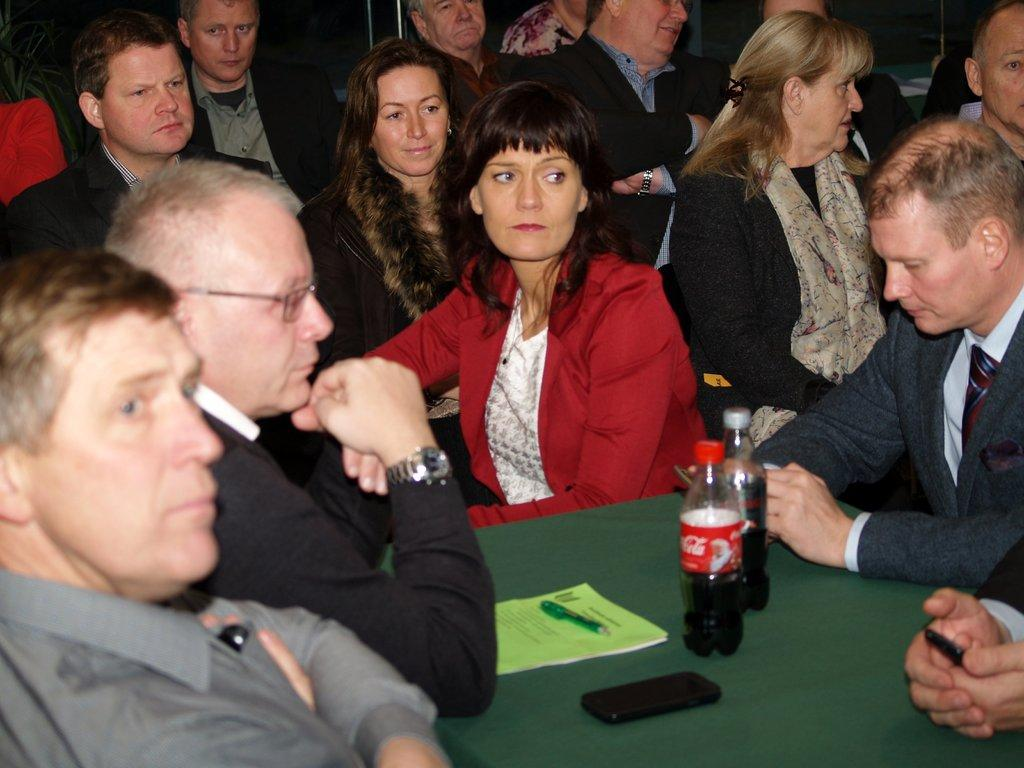What are the people in the image doing? There is a group of people sitting in the image. What is located at the bottom of the image? There is a table at the bottom of the image. What items can be seen on the table? There are two bottles, a book, a mobile phone, and a pen on the table. What type of sweater is the bird wearing in the image? There are no birds or sweaters present in the image. 